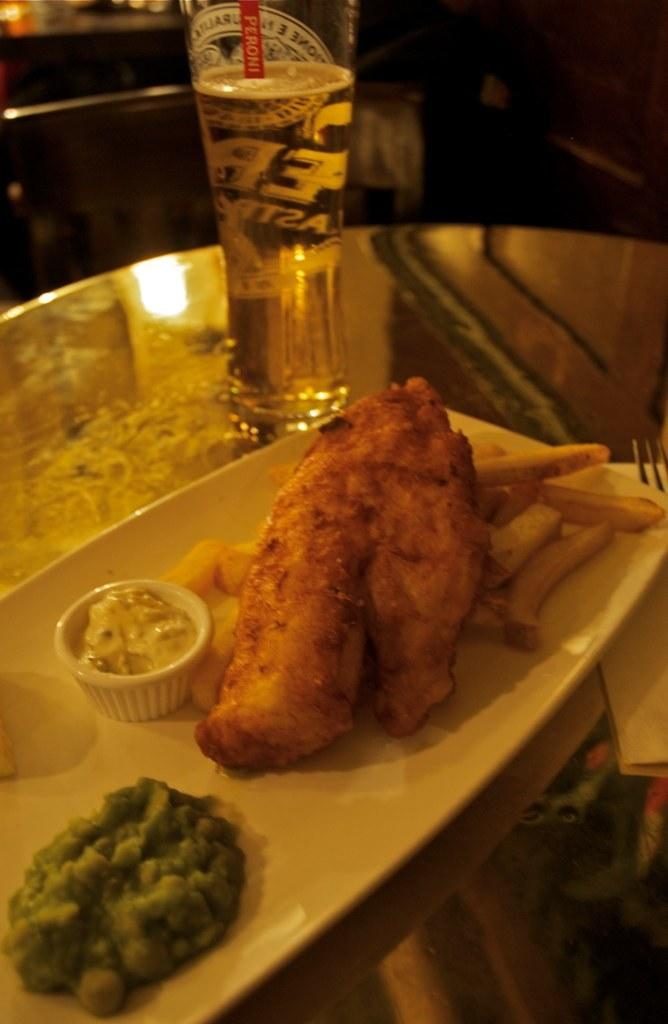Provide a one-sentence caption for the provided image. a fried fish and chips dinner with a glass of peroni. 